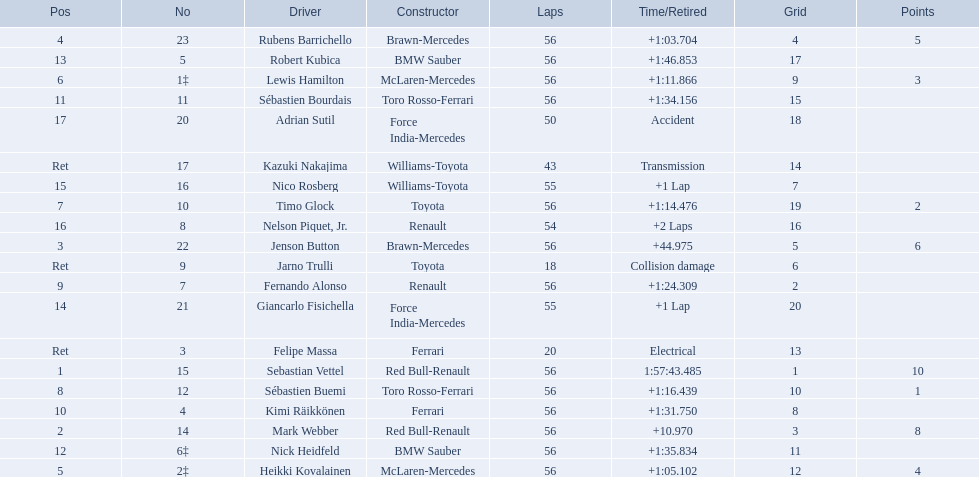Who were all the drivers? Sebastian Vettel, Mark Webber, Jenson Button, Rubens Barrichello, Heikki Kovalainen, Lewis Hamilton, Timo Glock, Sébastien Buemi, Fernando Alonso, Kimi Räikkönen, Sébastien Bourdais, Nick Heidfeld, Robert Kubica, Giancarlo Fisichella, Nico Rosberg, Nelson Piquet, Jr., Adrian Sutil, Kazuki Nakajima, Felipe Massa, Jarno Trulli. Which of these didn't have ferrari as a constructor? Sebastian Vettel, Mark Webber, Jenson Button, Rubens Barrichello, Heikki Kovalainen, Lewis Hamilton, Timo Glock, Sébastien Buemi, Fernando Alonso, Sébastien Bourdais, Nick Heidfeld, Robert Kubica, Giancarlo Fisichella, Nico Rosberg, Nelson Piquet, Jr., Adrian Sutil, Kazuki Nakajima, Jarno Trulli. Which of these was in first place? Sebastian Vettel. 